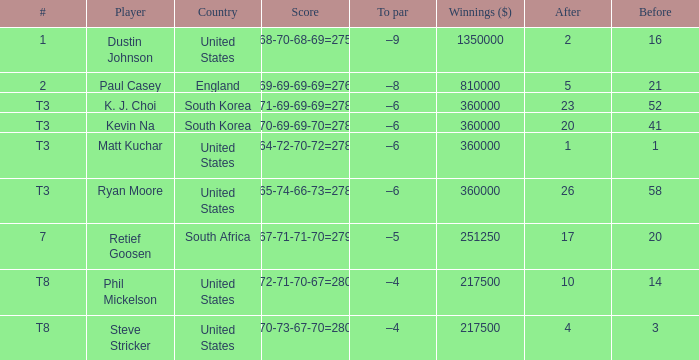How many times is  a to par listed when the player is phil mickelson? 1.0. 